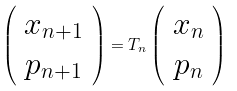<formula> <loc_0><loc_0><loc_500><loc_500>\left ( \begin{array} { c } x _ { n + 1 } \\ p _ { n + 1 } \\ \end{array} \right ) = { T } _ { n } \left ( \begin{array} { c } x _ { n } \\ p _ { n } \\ \end{array} \right )</formula> 